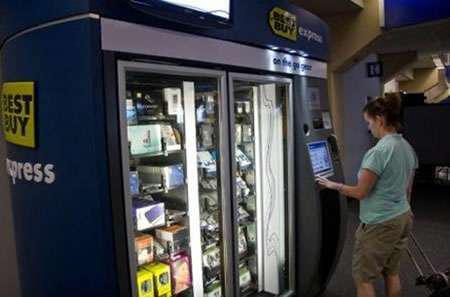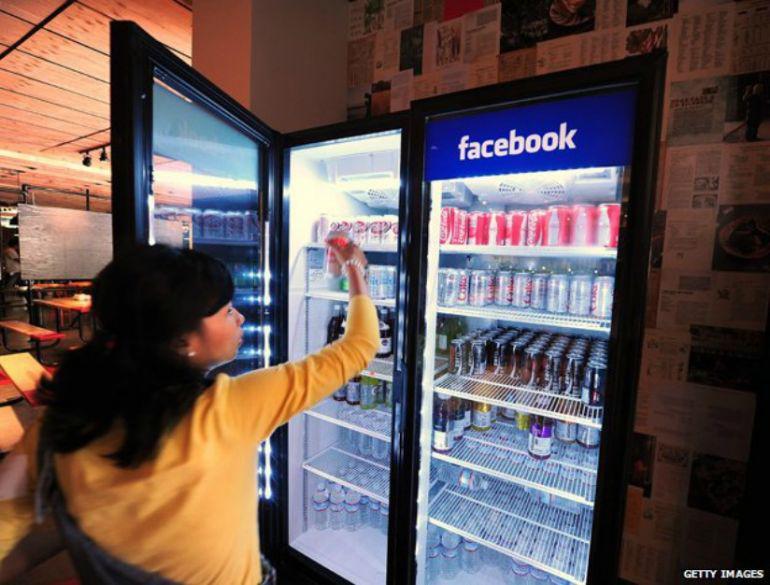The first image is the image on the left, the second image is the image on the right. Analyze the images presented: Is the assertion "In each image, at least one person is at a vending machine." valid? Answer yes or no. Yes. The first image is the image on the left, the second image is the image on the right. Evaluate the accuracy of this statement regarding the images: "There is a woman touching a vending machine.". Is it true? Answer yes or no. Yes. 